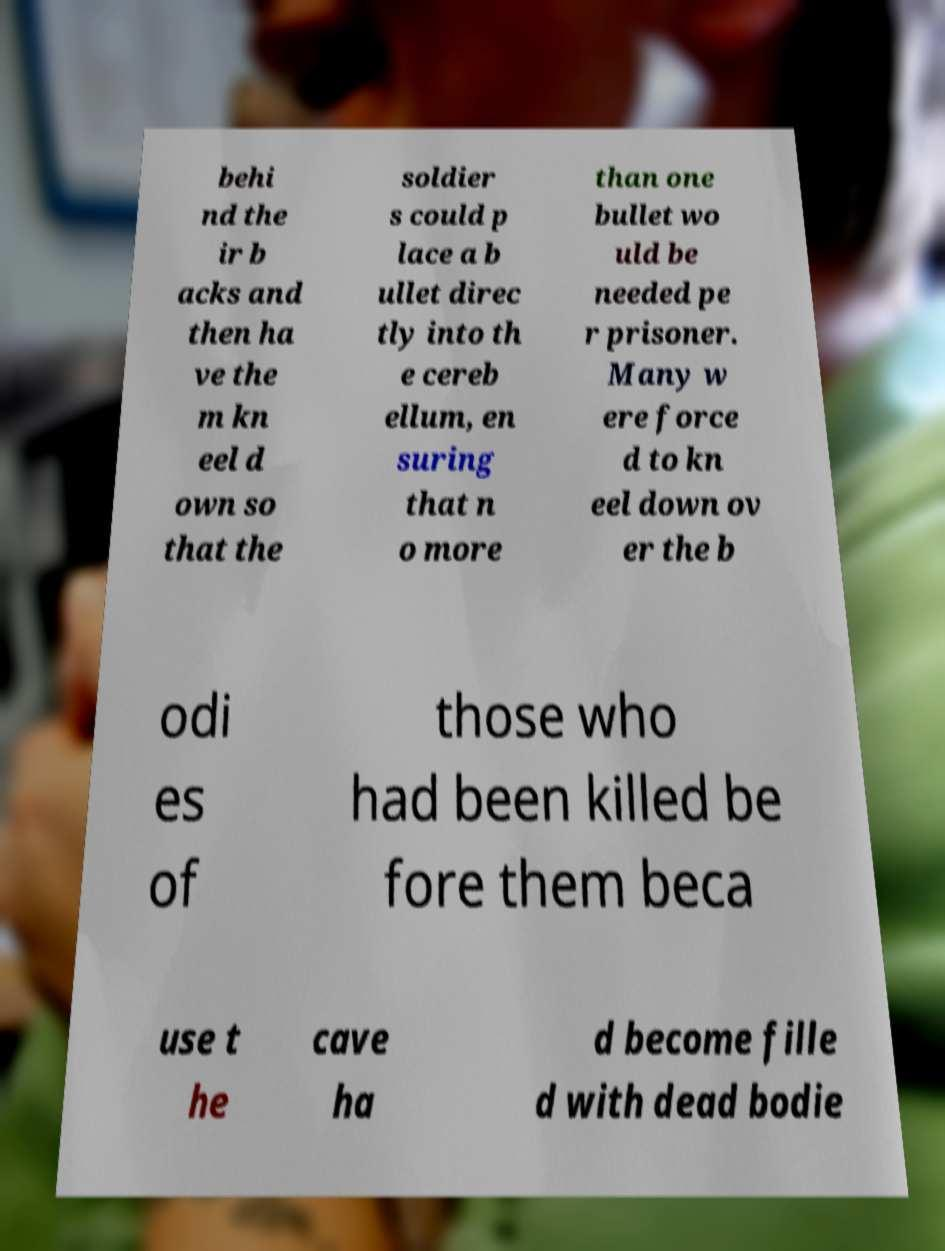What messages or text are displayed in this image? I need them in a readable, typed format. behi nd the ir b acks and then ha ve the m kn eel d own so that the soldier s could p lace a b ullet direc tly into th e cereb ellum, en suring that n o more than one bullet wo uld be needed pe r prisoner. Many w ere force d to kn eel down ov er the b odi es of those who had been killed be fore them beca use t he cave ha d become fille d with dead bodie 